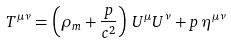Convert formula to latex. <formula><loc_0><loc_0><loc_500><loc_500>T ^ { \mu \nu } = \left ( \rho _ { m } + { \frac { p } { c ^ { 2 } } } \right ) \, U ^ { \mu } U ^ { \nu } + p \, \eta ^ { \mu \nu }</formula> 